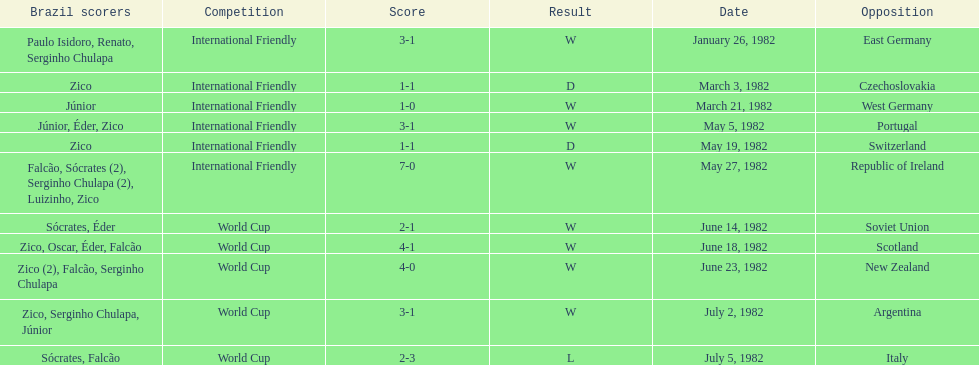What was the total number of losses brazil suffered? 1. 